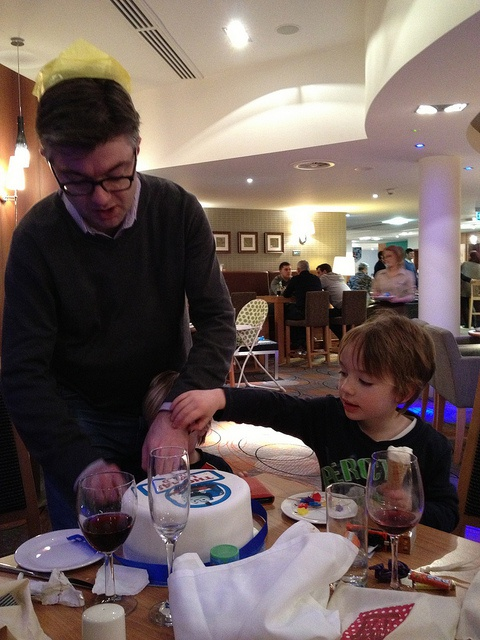Describe the objects in this image and their specific colors. I can see people in gray, black, maroon, and brown tones, dining table in gray, darkgray, black, and maroon tones, people in gray, black, maroon, and brown tones, cake in gray, darkgray, and lightgray tones, and wine glass in gray, black, maroon, and purple tones in this image. 